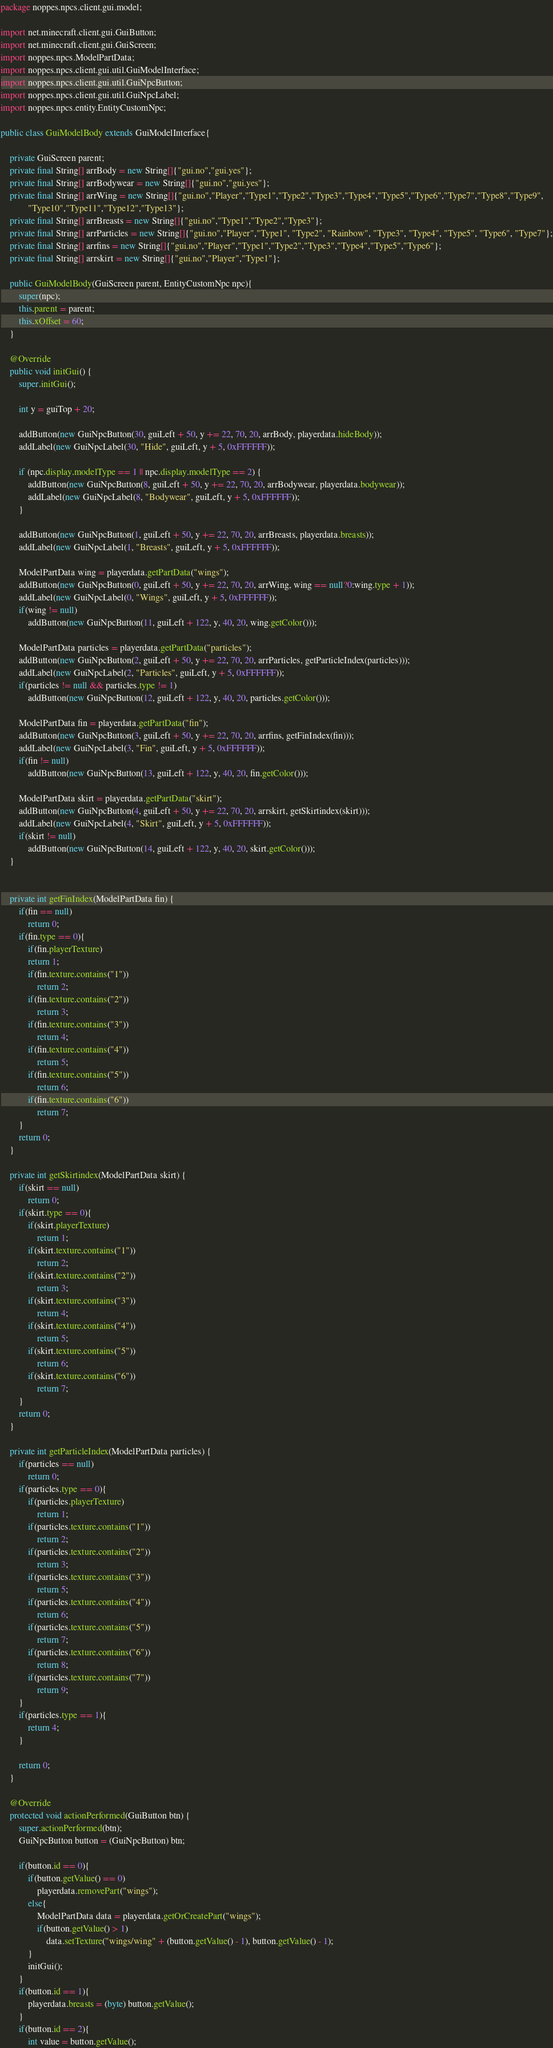<code> <loc_0><loc_0><loc_500><loc_500><_Java_>package noppes.npcs.client.gui.model;

import net.minecraft.client.gui.GuiButton;
import net.minecraft.client.gui.GuiScreen;
import noppes.npcs.ModelPartData;
import noppes.npcs.client.gui.util.GuiModelInterface;
import noppes.npcs.client.gui.util.GuiNpcButton;
import noppes.npcs.client.gui.util.GuiNpcLabel;
import noppes.npcs.entity.EntityCustomNpc;

public class GuiModelBody extends GuiModelInterface{

	private GuiScreen parent;
	private final String[] arrBody = new String[]{"gui.no","gui.yes"};
	private final String[] arrBodywear = new String[]{"gui.no","gui.yes"};
	private final String[] arrWing = new String[]{"gui.no","Player","Type1","Type2","Type3","Type4","Type5","Type6","Type7","Type8","Type9",
            "Type10","Type11","Type12","Type13"};
	private final String[] arrBreasts = new String[]{"gui.no","Type1","Type2","Type3"};
	private final String[] arrParticles = new String[]{"gui.no","Player","Type1", "Type2", "Rainbow", "Type3", "Type4", "Type5", "Type6", "Type7"};
	private final String[] arrfins = new String[]{"gui.no","Player","Type1","Type2","Type3","Type4","Type5","Type6"};
	private final String[] arrskirt = new String[]{"gui.no","Player","Type1"};
	
	public GuiModelBody(GuiScreen parent, EntityCustomNpc npc){
		super(npc);
		this.parent = parent;
		this.xOffset = 60;
	}

    @Override
    public void initGui() {
    	super.initGui();

		int y = guiTop + 20;

		addButton(new GuiNpcButton(30, guiLeft + 50, y += 22, 70, 20, arrBody, playerdata.hideBody));
		addLabel(new GuiNpcLabel(30, "Hide", guiLeft, y + 5, 0xFFFFFF));

		if (npc.display.modelType == 1 || npc.display.modelType == 2) {
			addButton(new GuiNpcButton(8, guiLeft + 50, y += 22, 70, 20, arrBodywear, playerdata.bodywear));
			addLabel(new GuiNpcLabel(8, "Bodywear", guiLeft, y + 5, 0xFFFFFF));
		}

    	addButton(new GuiNpcButton(1, guiLeft + 50, y += 22, 70, 20, arrBreasts, playerdata.breasts));
		addLabel(new GuiNpcLabel(1, "Breasts", guiLeft, y + 5, 0xFFFFFF));

		ModelPartData wing = playerdata.getPartData("wings");
    	addButton(new GuiNpcButton(0, guiLeft + 50, y += 22, 70, 20, arrWing, wing == null?0:wing.type + 1));
		addLabel(new GuiNpcLabel(0, "Wings", guiLeft, y + 5, 0xFFFFFF));
		if(wing != null)
			addButton(new GuiNpcButton(11, guiLeft + 122, y, 40, 20, wing.getColor()));

		ModelPartData particles = playerdata.getPartData("particles");
    	addButton(new GuiNpcButton(2, guiLeft + 50, y += 22, 70, 20, arrParticles, getParticleIndex(particles)));
		addLabel(new GuiNpcLabel(2, "Particles", guiLeft, y + 5, 0xFFFFFF));
		if(particles != null && particles.type != 1)
			addButton(new GuiNpcButton(12, guiLeft + 122, y, 40, 20, particles.getColor()));

		ModelPartData fin = playerdata.getPartData("fin");
    	addButton(new GuiNpcButton(3, guiLeft + 50, y += 22, 70, 20, arrfins, getFinIndex(fin)));
		addLabel(new GuiNpcLabel(3, "Fin", guiLeft, y + 5, 0xFFFFFF));
		if(fin != null)
			addButton(new GuiNpcButton(13, guiLeft + 122, y, 40, 20, fin.getColor()));

		ModelPartData skirt = playerdata.getPartData("skirt");
		addButton(new GuiNpcButton(4, guiLeft + 50, y += 22, 70, 20, arrskirt, getSkirtindex(skirt)));
		addLabel(new GuiNpcLabel(4, "Skirt", guiLeft, y + 5, 0xFFFFFF));
		if(skirt != null)
			addButton(new GuiNpcButton(14, guiLeft + 122, y, 40, 20, skirt.getColor()));
    }


    private int getFinIndex(ModelPartData fin) {
        if(fin == null)
            return 0;
        if(fin.type == 0){
            if(fin.playerTexture)
            return 1;
            if(fin.texture.contains("1"))
                return 2;
            if(fin.texture.contains("2"))
                return 3;
            if(fin.texture.contains("3"))
                return 4;
            if(fin.texture.contains("4"))
                return 5;
            if(fin.texture.contains("5"))
                return 6;
            if(fin.texture.contains("6"))
                return 7;
        }
        return 0;
	}

	private int getSkirtindex(ModelPartData skirt) {
		if(skirt == null)
			return 0;
		if(skirt.type == 0){
			if(skirt.playerTexture)
				return 1;
			if(skirt.texture.contains("1"))
				return 2;
			if(skirt.texture.contains("2"))
				return 3;
			if(skirt.texture.contains("3"))
				return 4;
			if(skirt.texture.contains("4"))
				return 5;
			if(skirt.texture.contains("5"))
				return 6;
			if(skirt.texture.contains("6"))
				return 7;
		}
		return 0;
	}

	private int getParticleIndex(ModelPartData particles) {
    	if(particles == null)
    		return 0;
    	if(particles.type == 0){
    		if(particles.playerTexture)
    			return 1;
    		if(particles.texture.contains("1"))
    			return 2;
    		if(particles.texture.contains("2"))
    			return 3;
			if(particles.texture.contains("3"))
				return 5;
			if(particles.texture.contains("4"))
				return 6;
			if(particles.texture.contains("5"))
				return 7;
			if(particles.texture.contains("6"))
				return 8;
			if(particles.texture.contains("7"))
				return 9;
    	}
    	if(particles.type == 1){
    		return 4;
    	}
    				
		return 0;
	}

	@Override
    protected void actionPerformed(GuiButton btn) {
    	super.actionPerformed(btn);
    	GuiNpcButton button = (GuiNpcButton) btn;

    	if(button.id == 0){
    		if(button.getValue() == 0)
    			playerdata.removePart("wings");
    		else{
    			ModelPartData data = playerdata.getOrCreatePart("wings");
    			if(button.getValue() > 1)
    				data.setTexture("wings/wing" + (button.getValue() - 1), button.getValue() - 1);
    		}
    		initGui();
    	}
    	if(button.id == 1){
    		playerdata.breasts = (byte) button.getValue();
    	}
    	if(button.id == 2){
    		int value = button.getValue();</code> 